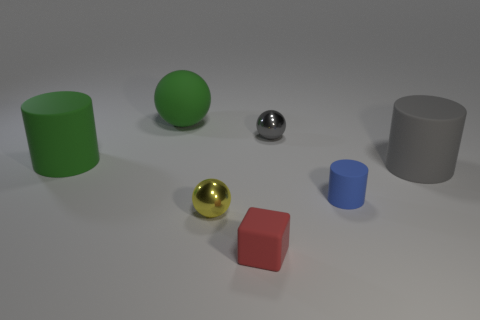What is the color of the metallic thing in front of the metal object that is to the right of the small rubber block?
Keep it short and to the point. Yellow. There is a rubber cylinder that is on the left side of the small gray metallic thing; is it the same color as the big matte ball?
Provide a succinct answer. Yes. What shape is the metal object that is left of the tiny rubber object that is in front of the small blue rubber thing that is in front of the gray shiny object?
Keep it short and to the point. Sphere. There is a cylinder on the left side of the red matte block; what number of matte cylinders are right of it?
Give a very brief answer. 2. Are the small gray thing and the green ball made of the same material?
Provide a short and direct response. No. How many large matte cylinders are left of the tiny shiny object in front of the big matte cylinder that is on the right side of the tiny blue cylinder?
Ensure brevity in your answer.  1. There is a rubber cylinder that is behind the large gray matte object; what color is it?
Your answer should be compact. Green. The gray thing in front of the rubber cylinder that is to the left of the tiny red matte thing is what shape?
Your answer should be very brief. Cylinder. What number of cylinders are either tiny gray objects or tiny red rubber objects?
Your answer should be compact. 0. What is the cylinder that is right of the yellow sphere and to the left of the large gray rubber cylinder made of?
Make the answer very short. Rubber. 